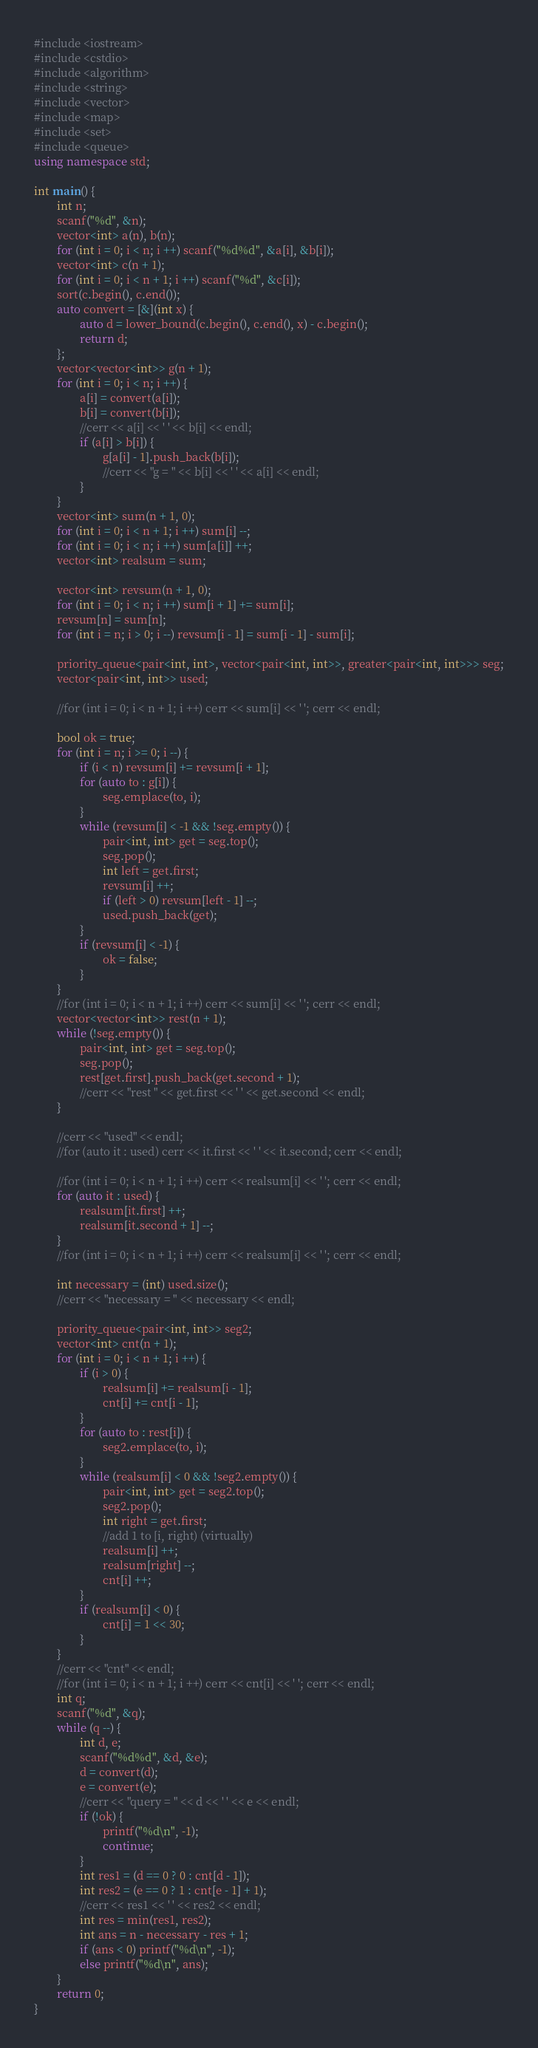<code> <loc_0><loc_0><loc_500><loc_500><_C++_>#include <iostream>
#include <cstdio>
#include <algorithm>
#include <string>
#include <vector>
#include <map>
#include <set>
#include <queue>
using namespace std;

int main() {
        int n;
        scanf("%d", &n);
        vector<int> a(n), b(n);
        for (int i = 0; i < n; i ++) scanf("%d%d", &a[i], &b[i]);
        vector<int> c(n + 1);
        for (int i = 0; i < n + 1; i ++) scanf("%d", &c[i]);
        sort(c.begin(), c.end());
        auto convert = [&](int x) {
                auto d = lower_bound(c.begin(), c.end(), x) - c.begin();
                return d;
        };
        vector<vector<int>> g(n + 1);
        for (int i = 0; i < n; i ++) {
                a[i] = convert(a[i]);
                b[i] = convert(b[i]);
                //cerr << a[i] << ' ' << b[i] << endl;
                if (a[i] > b[i]) { 
                        g[a[i] - 1].push_back(b[i]);
                        //cerr << "g = " << b[i] << ' ' << a[i] << endl;
                }
        }
        vector<int> sum(n + 1, 0);
        for (int i = 0; i < n + 1; i ++) sum[i] --;
        for (int i = 0; i < n; i ++) sum[a[i]] ++;
        vector<int> realsum = sum;

        vector<int> revsum(n + 1, 0);
        for (int i = 0; i < n; i ++) sum[i + 1] += sum[i];
        revsum[n] = sum[n];
        for (int i = n; i > 0; i --) revsum[i - 1] = sum[i - 1] - sum[i];

        priority_queue<pair<int, int>, vector<pair<int, int>>, greater<pair<int, int>>> seg;
        vector<pair<int, int>> used;

        //for (int i = 0; i < n + 1; i ++) cerr << sum[i] << ' '; cerr << endl;

        bool ok = true;
        for (int i = n; i >= 0; i --) {
                if (i < n) revsum[i] += revsum[i + 1];
                for (auto to : g[i]) {
                        seg.emplace(to, i);
                }
                while (revsum[i] < -1 && !seg.empty()) {
                        pair<int, int> get = seg.top();
                        seg.pop();
                        int left = get.first;
                        revsum[i] ++;
                        if (left > 0) revsum[left - 1] --;
                        used.push_back(get);
                }
                if (revsum[i] < -1) {
                        ok = false;
                }
        }
        //for (int i = 0; i < n + 1; i ++) cerr << sum[i] << ' '; cerr << endl;
        vector<vector<int>> rest(n + 1);
        while (!seg.empty()) {
                pair<int, int> get = seg.top();
                seg.pop();
                rest[get.first].push_back(get.second + 1);
                //cerr << "rest " << get.first << ' ' << get.second << endl;
        }

        //cerr << "used" << endl;
        //for (auto it : used) cerr << it.first << ' ' << it.second; cerr << endl;

        //for (int i = 0; i < n + 1; i ++) cerr << realsum[i] << ' '; cerr << endl;
        for (auto it : used) {
                realsum[it.first] ++;
                realsum[it.second + 1] --;
        }
        //for (int i = 0; i < n + 1; i ++) cerr << realsum[i] << ' '; cerr << endl;

        int necessary = (int) used.size();
        //cerr << "necessary = " << necessary << endl;

        priority_queue<pair<int, int>> seg2;
        vector<int> cnt(n + 1);
        for (int i = 0; i < n + 1; i ++) {
                if (i > 0) { 
                        realsum[i] += realsum[i - 1];
                        cnt[i] += cnt[i - 1];
                }
                for (auto to : rest[i]) {
                        seg2.emplace(to, i);
                }
                while (realsum[i] < 0 && !seg2.empty()) {
                        pair<int, int> get = seg2.top();
                        seg2.pop();
                        int right = get.first;
                        //add 1 to [i, right) (virtually)
                        realsum[i] ++;
                        realsum[right] --;
                        cnt[i] ++;
                }
                if (realsum[i] < 0) {
                        cnt[i] = 1 << 30;
                }
        }
        //cerr << "cnt" << endl;
        //for (int i = 0; i < n + 1; i ++) cerr << cnt[i] << ' '; cerr << endl;
        int q;
        scanf("%d", &q);
        while (q --) {
                int d, e;
                scanf("%d%d", &d, &e);
                d = convert(d);
                e = convert(e);
                //cerr << "query = " << d << ' ' << e << endl;
                if (!ok) {
                        printf("%d\n", -1);
                        continue;
                }
                int res1 = (d == 0 ? 0 : cnt[d - 1]);
                int res2 = (e == 0 ? 1 : cnt[e - 1] + 1);
                //cerr << res1 << ' ' << res2 << endl;
                int res = min(res1, res2);
                int ans = n - necessary - res + 1;
                if (ans < 0) printf("%d\n", -1);
                else printf("%d\n", ans);
        }                                      
        return 0;
}
</code> 